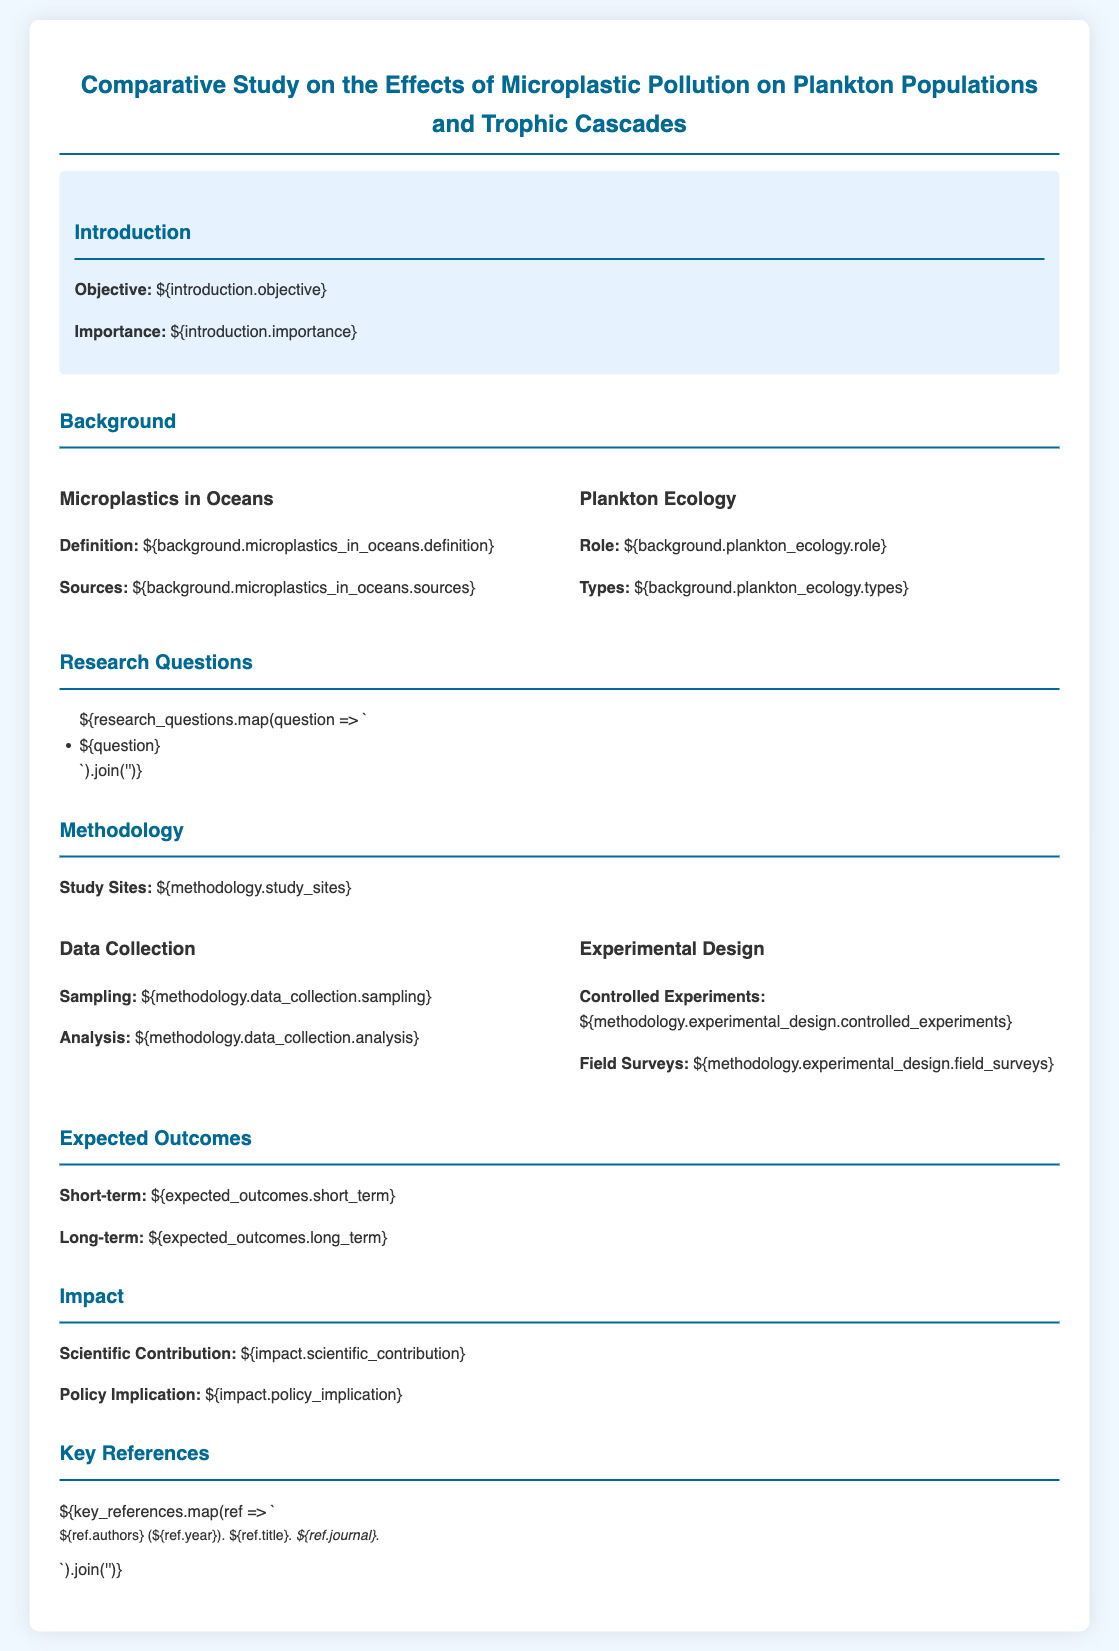What is the objective of the study? The objective is stated in the introduction section of the proposal, which summarizes the main aim of the comparative study.
Answer: Comparative study on microplastic pollution's effects What are the types of plankton mentioned? The types of plankton are detailed under "Plankton Ecology" in the background section, providing insights into various classifications.
Answer: Types of plankton What is the short-term expected outcome? The short-term expected outcome is listed in the expected outcomes section, summarizing the immediate findings anticipated from the research.
Answer: Short-term outcomes How many study sites are mentioned? The number of study sites is specified in the methodology section, indicating where the research will take place.
Answer: Number of study sites What controlled experiments are detailed in the methodology? The controlled experiments are described in the methodology section, outlining the specific designs for the research experiments.
Answer: Controlled experiments in methodology What is the scientific contribution anticipated from this study? The scientific contribution is highlighted under the impact section, explaining the potential advancements in knowledge stemming from the research.
Answer: Scientific contribution What do the field surveys involve? The details of the field surveys are found under the methodological section, specifying how the research will be conducted in natural settings.
Answer: Field surveys details 